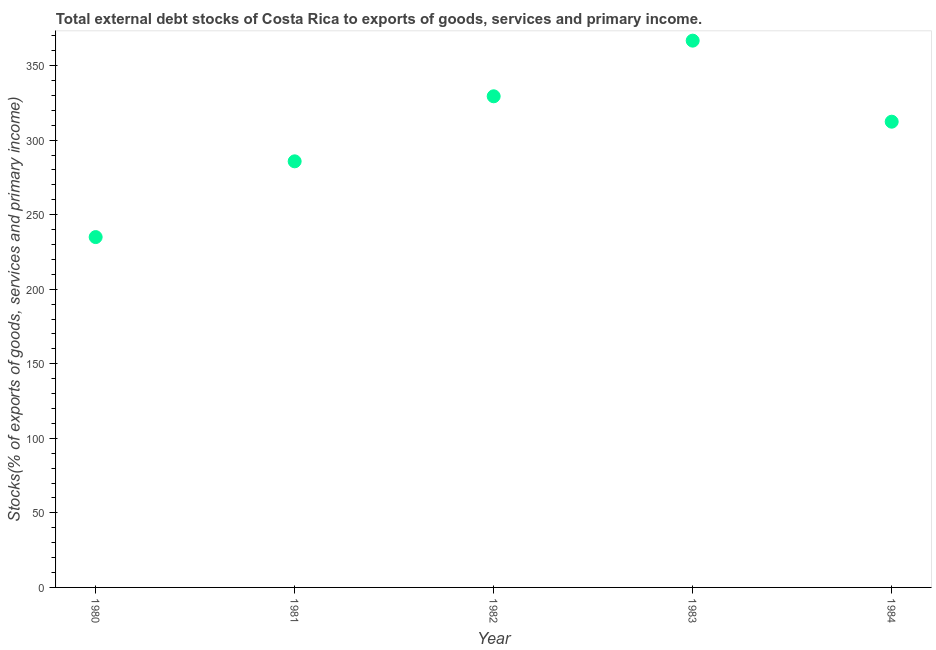What is the external debt stocks in 1982?
Provide a succinct answer. 329.42. Across all years, what is the maximum external debt stocks?
Provide a succinct answer. 366.74. Across all years, what is the minimum external debt stocks?
Your answer should be very brief. 234.98. In which year was the external debt stocks maximum?
Offer a very short reply. 1983. In which year was the external debt stocks minimum?
Keep it short and to the point. 1980. What is the sum of the external debt stocks?
Your answer should be very brief. 1529.33. What is the difference between the external debt stocks in 1980 and 1981?
Keep it short and to the point. -50.81. What is the average external debt stocks per year?
Provide a succinct answer. 305.87. What is the median external debt stocks?
Ensure brevity in your answer.  312.38. Do a majority of the years between 1982 and 1980 (inclusive) have external debt stocks greater than 90 %?
Give a very brief answer. No. What is the ratio of the external debt stocks in 1981 to that in 1982?
Give a very brief answer. 0.87. Is the external debt stocks in 1981 less than that in 1984?
Provide a short and direct response. Yes. What is the difference between the highest and the second highest external debt stocks?
Your response must be concise. 37.32. What is the difference between the highest and the lowest external debt stocks?
Your answer should be very brief. 131.76. In how many years, is the external debt stocks greater than the average external debt stocks taken over all years?
Give a very brief answer. 3. How many dotlines are there?
Your answer should be very brief. 1. How many years are there in the graph?
Your answer should be very brief. 5. What is the difference between two consecutive major ticks on the Y-axis?
Give a very brief answer. 50. Does the graph contain grids?
Make the answer very short. No. What is the title of the graph?
Make the answer very short. Total external debt stocks of Costa Rica to exports of goods, services and primary income. What is the label or title of the X-axis?
Offer a terse response. Year. What is the label or title of the Y-axis?
Your answer should be compact. Stocks(% of exports of goods, services and primary income). What is the Stocks(% of exports of goods, services and primary income) in 1980?
Offer a very short reply. 234.98. What is the Stocks(% of exports of goods, services and primary income) in 1981?
Your answer should be compact. 285.8. What is the Stocks(% of exports of goods, services and primary income) in 1982?
Your answer should be very brief. 329.42. What is the Stocks(% of exports of goods, services and primary income) in 1983?
Offer a very short reply. 366.74. What is the Stocks(% of exports of goods, services and primary income) in 1984?
Keep it short and to the point. 312.38. What is the difference between the Stocks(% of exports of goods, services and primary income) in 1980 and 1981?
Ensure brevity in your answer.  -50.81. What is the difference between the Stocks(% of exports of goods, services and primary income) in 1980 and 1982?
Your answer should be very brief. -94.44. What is the difference between the Stocks(% of exports of goods, services and primary income) in 1980 and 1983?
Offer a terse response. -131.76. What is the difference between the Stocks(% of exports of goods, services and primary income) in 1980 and 1984?
Your answer should be compact. -77.4. What is the difference between the Stocks(% of exports of goods, services and primary income) in 1981 and 1982?
Give a very brief answer. -43.62. What is the difference between the Stocks(% of exports of goods, services and primary income) in 1981 and 1983?
Make the answer very short. -80.95. What is the difference between the Stocks(% of exports of goods, services and primary income) in 1981 and 1984?
Your answer should be very brief. -26.58. What is the difference between the Stocks(% of exports of goods, services and primary income) in 1982 and 1983?
Offer a very short reply. -37.32. What is the difference between the Stocks(% of exports of goods, services and primary income) in 1982 and 1984?
Provide a succinct answer. 17.04. What is the difference between the Stocks(% of exports of goods, services and primary income) in 1983 and 1984?
Your response must be concise. 54.36. What is the ratio of the Stocks(% of exports of goods, services and primary income) in 1980 to that in 1981?
Your answer should be compact. 0.82. What is the ratio of the Stocks(% of exports of goods, services and primary income) in 1980 to that in 1982?
Your answer should be compact. 0.71. What is the ratio of the Stocks(% of exports of goods, services and primary income) in 1980 to that in 1983?
Make the answer very short. 0.64. What is the ratio of the Stocks(% of exports of goods, services and primary income) in 1980 to that in 1984?
Keep it short and to the point. 0.75. What is the ratio of the Stocks(% of exports of goods, services and primary income) in 1981 to that in 1982?
Provide a succinct answer. 0.87. What is the ratio of the Stocks(% of exports of goods, services and primary income) in 1981 to that in 1983?
Provide a short and direct response. 0.78. What is the ratio of the Stocks(% of exports of goods, services and primary income) in 1981 to that in 1984?
Make the answer very short. 0.92. What is the ratio of the Stocks(% of exports of goods, services and primary income) in 1982 to that in 1983?
Provide a succinct answer. 0.9. What is the ratio of the Stocks(% of exports of goods, services and primary income) in 1982 to that in 1984?
Keep it short and to the point. 1.05. What is the ratio of the Stocks(% of exports of goods, services and primary income) in 1983 to that in 1984?
Give a very brief answer. 1.17. 